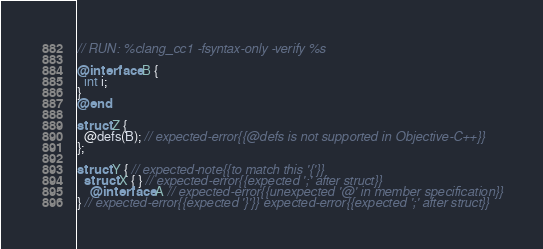<code> <loc_0><loc_0><loc_500><loc_500><_ObjectiveC_>// RUN: %clang_cc1 -fsyntax-only -verify %s

@interface B {
  int i;
}
@end

struct Z {
  @defs(B); // expected-error{{@defs is not supported in Objective-C++}}
};

struct Y { // expected-note{{to match this '{'}}
  struct X { } // expected-error{{expected ';' after struct}}
    @interface A // expected-error{{unexpected '@' in member specification}}
} // expected-error{{expected '}'}} expected-error{{expected ';' after struct}}
</code> 